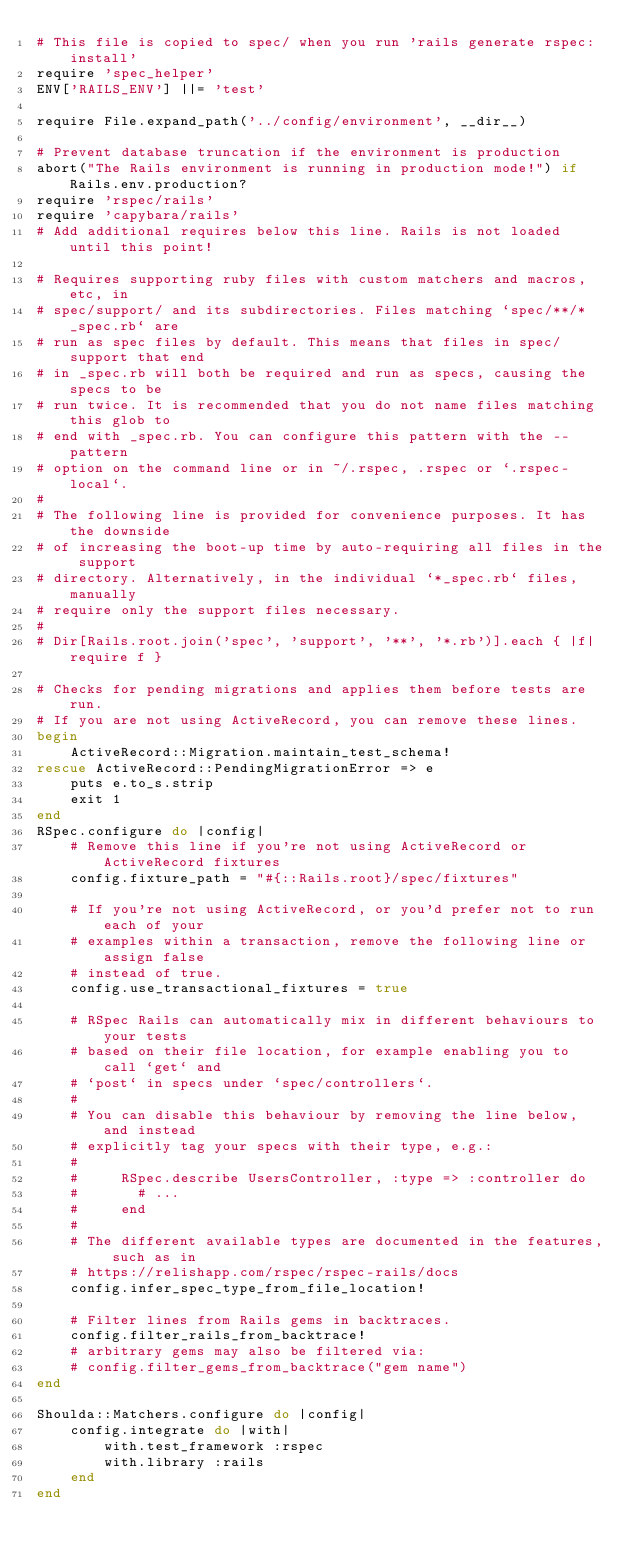Convert code to text. <code><loc_0><loc_0><loc_500><loc_500><_Ruby_># This file is copied to spec/ when you run 'rails generate rspec:install'
require 'spec_helper'
ENV['RAILS_ENV'] ||= 'test'

require File.expand_path('../config/environment', __dir__)

# Prevent database truncation if the environment is production
abort("The Rails environment is running in production mode!") if Rails.env.production?
require 'rspec/rails'
require 'capybara/rails'
# Add additional requires below this line. Rails is not loaded until this point!

# Requires supporting ruby files with custom matchers and macros, etc, in
# spec/support/ and its subdirectories. Files matching `spec/**/*_spec.rb` are
# run as spec files by default. This means that files in spec/support that end
# in _spec.rb will both be required and run as specs, causing the specs to be
# run twice. It is recommended that you do not name files matching this glob to
# end with _spec.rb. You can configure this pattern with the --pattern
# option on the command line or in ~/.rspec, .rspec or `.rspec-local`.
#
# The following line is provided for convenience purposes. It has the downside
# of increasing the boot-up time by auto-requiring all files in the support
# directory. Alternatively, in the individual `*_spec.rb` files, manually
# require only the support files necessary.
#
# Dir[Rails.root.join('spec', 'support', '**', '*.rb')].each { |f| require f }

# Checks for pending migrations and applies them before tests are run.
# If you are not using ActiveRecord, you can remove these lines.
begin
    ActiveRecord::Migration.maintain_test_schema!
rescue ActiveRecord::PendingMigrationError => e
    puts e.to_s.strip
    exit 1
end
RSpec.configure do |config|
    # Remove this line if you're not using ActiveRecord or ActiveRecord fixtures
    config.fixture_path = "#{::Rails.root}/spec/fixtures"

    # If you're not using ActiveRecord, or you'd prefer not to run each of your
    # examples within a transaction, remove the following line or assign false
    # instead of true.
    config.use_transactional_fixtures = true

    # RSpec Rails can automatically mix in different behaviours to your tests
    # based on their file location, for example enabling you to call `get` and
    # `post` in specs under `spec/controllers`.
    #
    # You can disable this behaviour by removing the line below, and instead
    # explicitly tag your specs with their type, e.g.:
    #
    #     RSpec.describe UsersController, :type => :controller do
    #       # ...
    #     end
    #
    # The different available types are documented in the features, such as in
    # https://relishapp.com/rspec/rspec-rails/docs
    config.infer_spec_type_from_file_location!

    # Filter lines from Rails gems in backtraces.
    config.filter_rails_from_backtrace!
    # arbitrary gems may also be filtered via:
    # config.filter_gems_from_backtrace("gem name")
end

Shoulda::Matchers.configure do |config|
    config.integrate do |with|
        with.test_framework :rspec
        with.library :rails
    end
end
</code> 